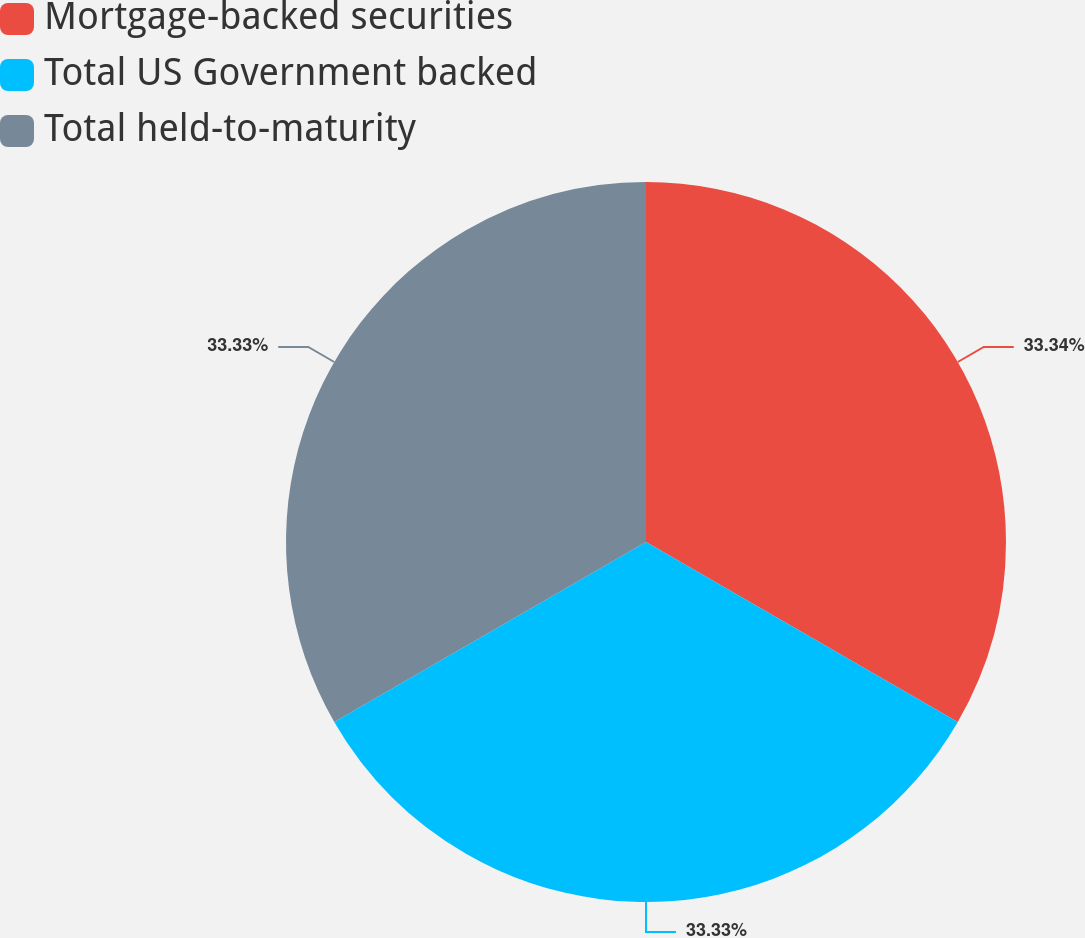<chart> <loc_0><loc_0><loc_500><loc_500><pie_chart><fcel>Mortgage-backed securities<fcel>Total US Government backed<fcel>Total held-to-maturity<nl><fcel>33.33%<fcel>33.33%<fcel>33.33%<nl></chart> 